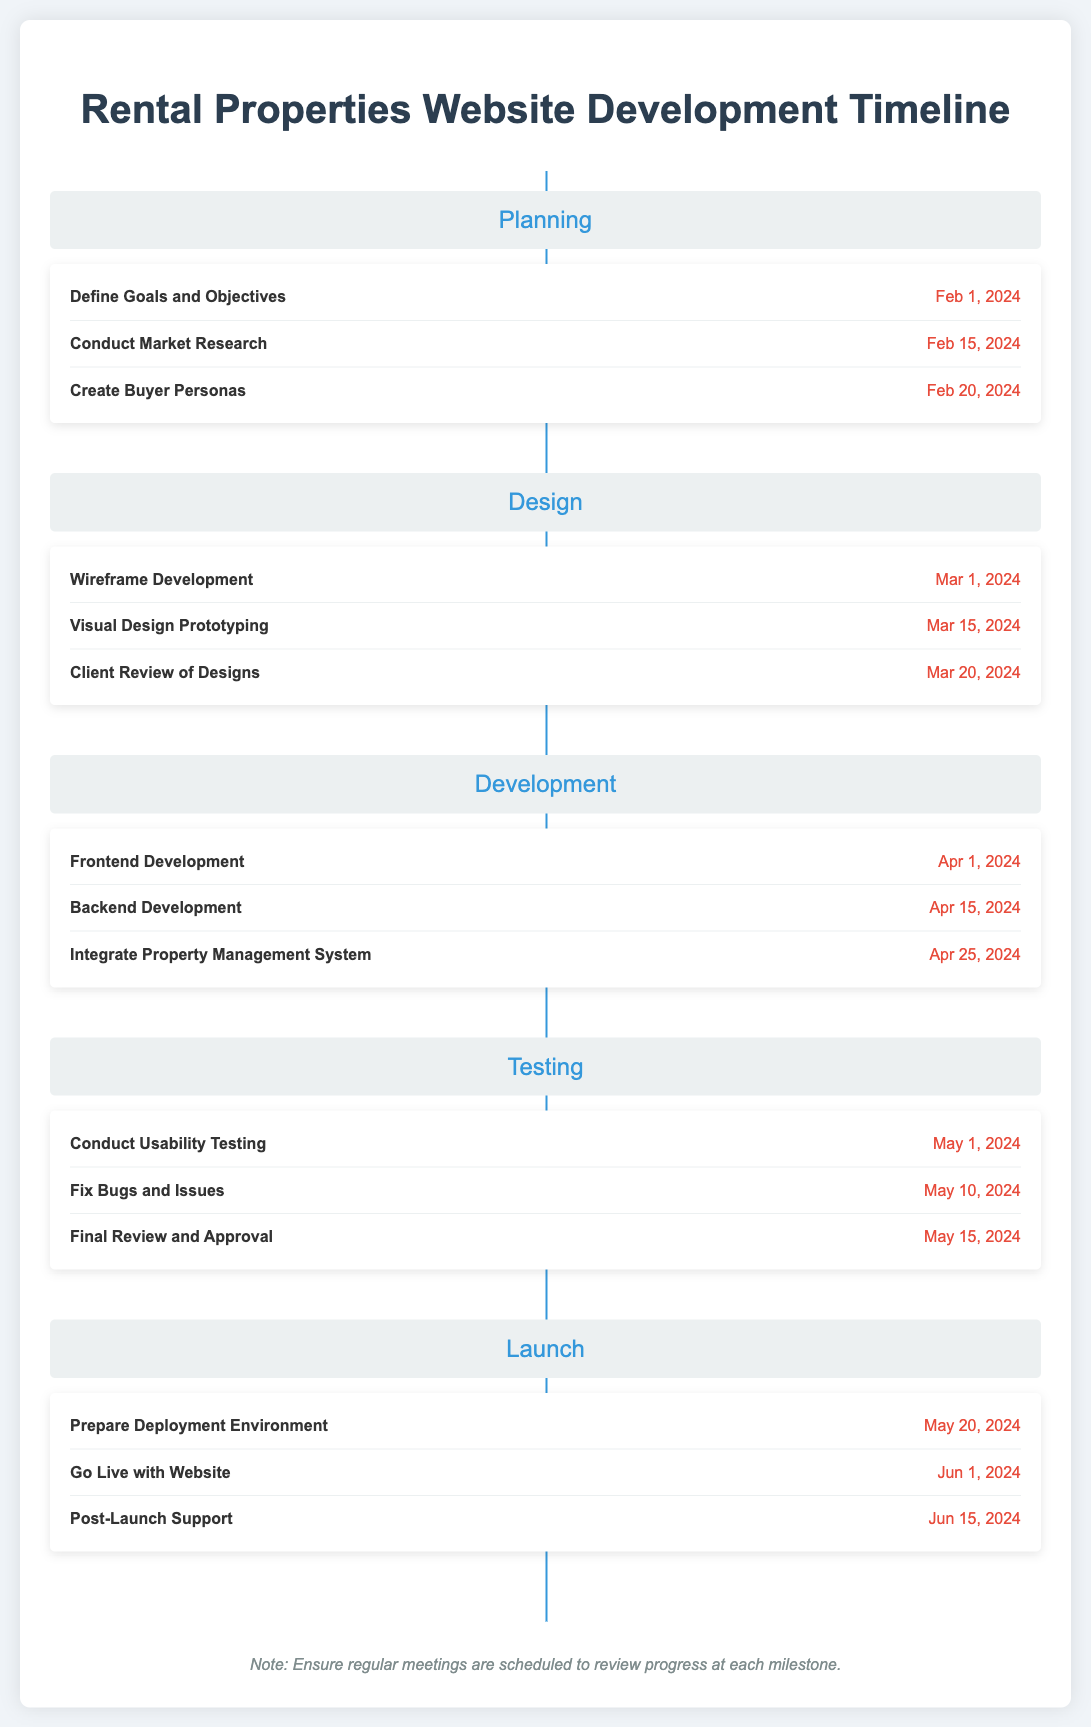what is the deadline for defining goals and objectives? The deadline for defining goals and objectives is specified in the document under the "Planning" phase, which is February 1, 2024.
Answer: February 1, 2024 what is the last task listed in the Development phase? The last task listed in the Development phase is to integrate the property management system, which is on April 25, 2024.
Answer: Integrate Property Management System how many tasks are there in the Testing phase? The Testing phase contains three tasks as listed in the document.
Answer: 3 what is the date for the final review and approval? The document specifies the date for the final review and approval task in the Testing phase, which is May 15, 2024.
Answer: May 15, 2024 when does the website go live? The document states that the website is scheduled to go live on June 1, 2024.
Answer: June 1, 2024 which phase comes after the Design phase? The phases are listed sequentially in the timeline, with Development following Design.
Answer: Development what phase follows Testing in the timeline? According to the document, the Launch phase follows the Testing phase.
Answer: Launch what is the color of the phase titles? The phase titles are colored in a specific shade identified in the document as #3498db.
Answer: #3498db 